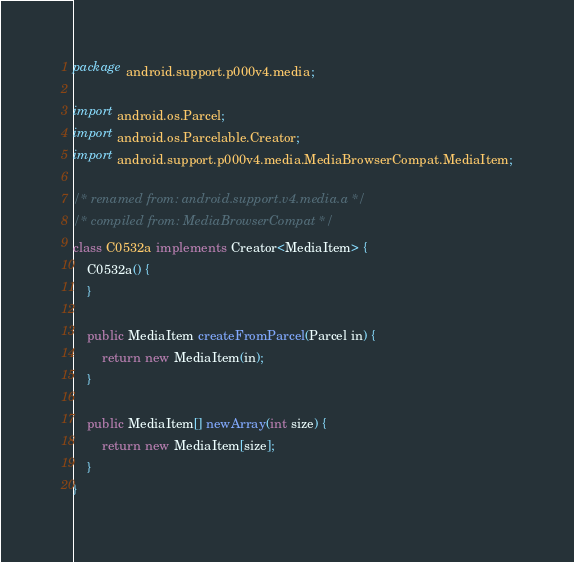<code> <loc_0><loc_0><loc_500><loc_500><_Java_>package android.support.p000v4.media;

import android.os.Parcel;
import android.os.Parcelable.Creator;
import android.support.p000v4.media.MediaBrowserCompat.MediaItem;

/* renamed from: android.support.v4.media.a */
/* compiled from: MediaBrowserCompat */
class C0532a implements Creator<MediaItem> {
    C0532a() {
    }

    public MediaItem createFromParcel(Parcel in) {
        return new MediaItem(in);
    }

    public MediaItem[] newArray(int size) {
        return new MediaItem[size];
    }
}
</code> 